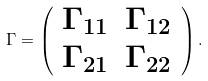Convert formula to latex. <formula><loc_0><loc_0><loc_500><loc_500>\Gamma = \left ( \begin{array} { c c } \Gamma _ { 1 1 } & \Gamma _ { 1 2 } \\ \Gamma _ { 2 1 } & \Gamma _ { 2 2 } \end{array} \right ) .</formula> 